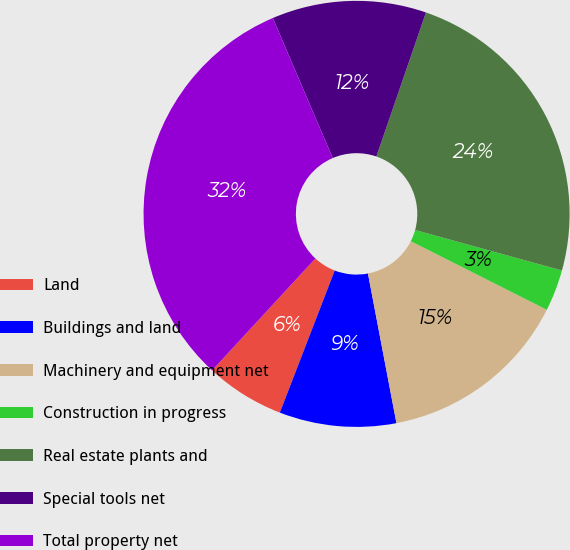<chart> <loc_0><loc_0><loc_500><loc_500><pie_chart><fcel>Land<fcel>Buildings and land<fcel>Machinery and equipment net<fcel>Construction in progress<fcel>Real estate plants and<fcel>Special tools net<fcel>Total property net<nl><fcel>6.0%<fcel>8.86%<fcel>14.57%<fcel>3.15%<fcel>24.0%<fcel>11.71%<fcel>31.7%<nl></chart> 